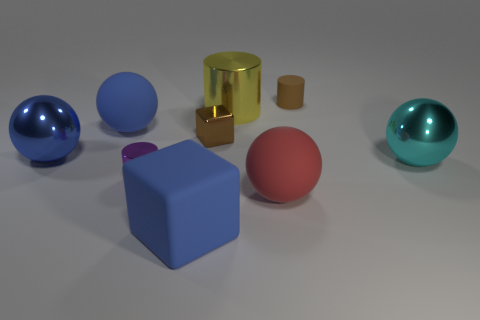There is a brown thing to the right of the brown shiny thing; does it have the same shape as the small brown metal thing?
Offer a very short reply. No. What number of large balls are behind the red rubber sphere and right of the small purple thing?
Make the answer very short. 1. What number of other objects are the same size as the blue cube?
Give a very brief answer. 5. Are there an equal number of big red objects on the right side of the tiny brown rubber object and large gray shiny cylinders?
Give a very brief answer. Yes. There is a big matte thing that is behind the large cyan ball; does it have the same color as the big metallic sphere that is to the left of the yellow metal cylinder?
Ensure brevity in your answer.  Yes. What is the material of the ball that is on the right side of the purple metallic object and to the left of the brown cylinder?
Give a very brief answer. Rubber. The big rubber block is what color?
Offer a very short reply. Blue. What number of other things are there of the same shape as the purple thing?
Your answer should be very brief. 2. Is the number of large cyan things in front of the big red matte sphere the same as the number of large yellow things behind the big yellow cylinder?
Provide a short and direct response. Yes. What material is the tiny brown cylinder?
Your response must be concise. Rubber. 